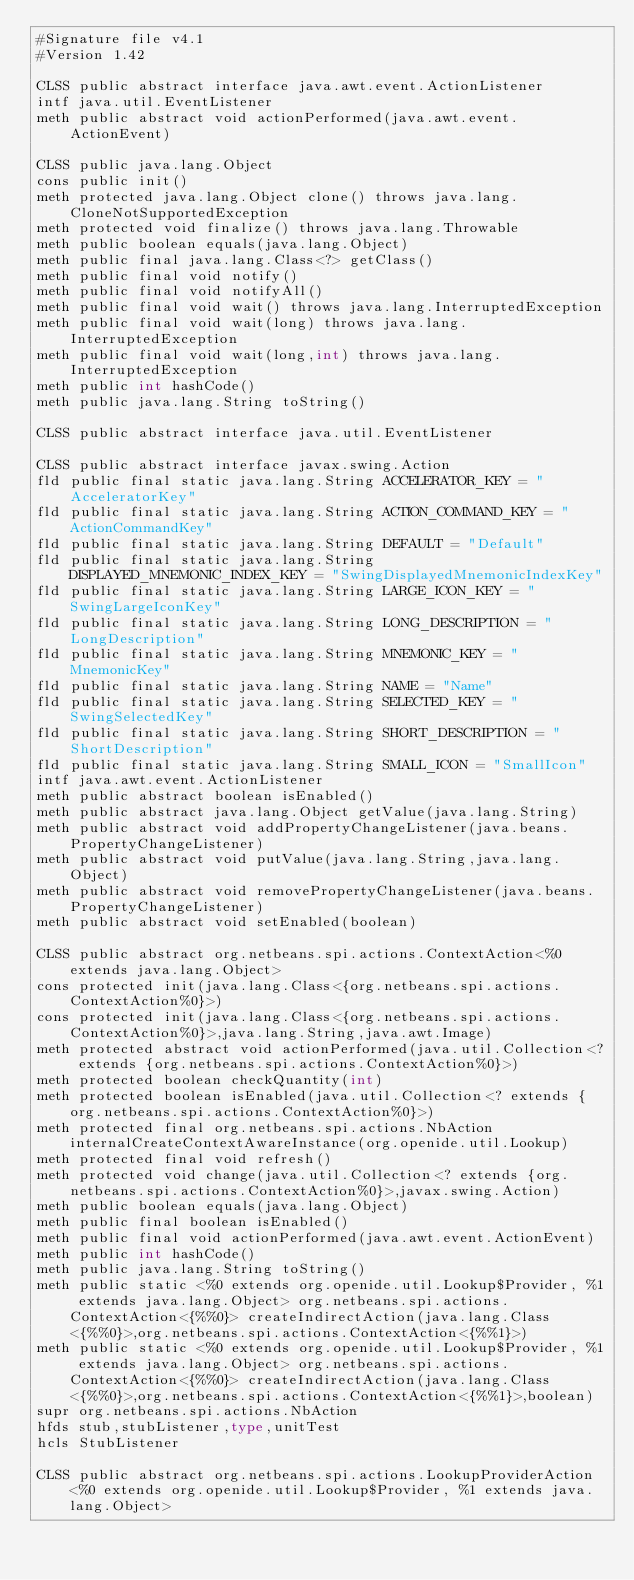Convert code to text. <code><loc_0><loc_0><loc_500><loc_500><_SML_>#Signature file v4.1
#Version 1.42

CLSS public abstract interface java.awt.event.ActionListener
intf java.util.EventListener
meth public abstract void actionPerformed(java.awt.event.ActionEvent)

CLSS public java.lang.Object
cons public init()
meth protected java.lang.Object clone() throws java.lang.CloneNotSupportedException
meth protected void finalize() throws java.lang.Throwable
meth public boolean equals(java.lang.Object)
meth public final java.lang.Class<?> getClass()
meth public final void notify()
meth public final void notifyAll()
meth public final void wait() throws java.lang.InterruptedException
meth public final void wait(long) throws java.lang.InterruptedException
meth public final void wait(long,int) throws java.lang.InterruptedException
meth public int hashCode()
meth public java.lang.String toString()

CLSS public abstract interface java.util.EventListener

CLSS public abstract interface javax.swing.Action
fld public final static java.lang.String ACCELERATOR_KEY = "AcceleratorKey"
fld public final static java.lang.String ACTION_COMMAND_KEY = "ActionCommandKey"
fld public final static java.lang.String DEFAULT = "Default"
fld public final static java.lang.String DISPLAYED_MNEMONIC_INDEX_KEY = "SwingDisplayedMnemonicIndexKey"
fld public final static java.lang.String LARGE_ICON_KEY = "SwingLargeIconKey"
fld public final static java.lang.String LONG_DESCRIPTION = "LongDescription"
fld public final static java.lang.String MNEMONIC_KEY = "MnemonicKey"
fld public final static java.lang.String NAME = "Name"
fld public final static java.lang.String SELECTED_KEY = "SwingSelectedKey"
fld public final static java.lang.String SHORT_DESCRIPTION = "ShortDescription"
fld public final static java.lang.String SMALL_ICON = "SmallIcon"
intf java.awt.event.ActionListener
meth public abstract boolean isEnabled()
meth public abstract java.lang.Object getValue(java.lang.String)
meth public abstract void addPropertyChangeListener(java.beans.PropertyChangeListener)
meth public abstract void putValue(java.lang.String,java.lang.Object)
meth public abstract void removePropertyChangeListener(java.beans.PropertyChangeListener)
meth public abstract void setEnabled(boolean)

CLSS public abstract org.netbeans.spi.actions.ContextAction<%0 extends java.lang.Object>
cons protected init(java.lang.Class<{org.netbeans.spi.actions.ContextAction%0}>)
cons protected init(java.lang.Class<{org.netbeans.spi.actions.ContextAction%0}>,java.lang.String,java.awt.Image)
meth protected abstract void actionPerformed(java.util.Collection<? extends {org.netbeans.spi.actions.ContextAction%0}>)
meth protected boolean checkQuantity(int)
meth protected boolean isEnabled(java.util.Collection<? extends {org.netbeans.spi.actions.ContextAction%0}>)
meth protected final org.netbeans.spi.actions.NbAction internalCreateContextAwareInstance(org.openide.util.Lookup)
meth protected final void refresh()
meth protected void change(java.util.Collection<? extends {org.netbeans.spi.actions.ContextAction%0}>,javax.swing.Action)
meth public boolean equals(java.lang.Object)
meth public final boolean isEnabled()
meth public final void actionPerformed(java.awt.event.ActionEvent)
meth public int hashCode()
meth public java.lang.String toString()
meth public static <%0 extends org.openide.util.Lookup$Provider, %1 extends java.lang.Object> org.netbeans.spi.actions.ContextAction<{%%0}> createIndirectAction(java.lang.Class<{%%0}>,org.netbeans.spi.actions.ContextAction<{%%1}>)
meth public static <%0 extends org.openide.util.Lookup$Provider, %1 extends java.lang.Object> org.netbeans.spi.actions.ContextAction<{%%0}> createIndirectAction(java.lang.Class<{%%0}>,org.netbeans.spi.actions.ContextAction<{%%1}>,boolean)
supr org.netbeans.spi.actions.NbAction
hfds stub,stubListener,type,unitTest
hcls StubListener

CLSS public abstract org.netbeans.spi.actions.LookupProviderAction<%0 extends org.openide.util.Lookup$Provider, %1 extends java.lang.Object></code> 